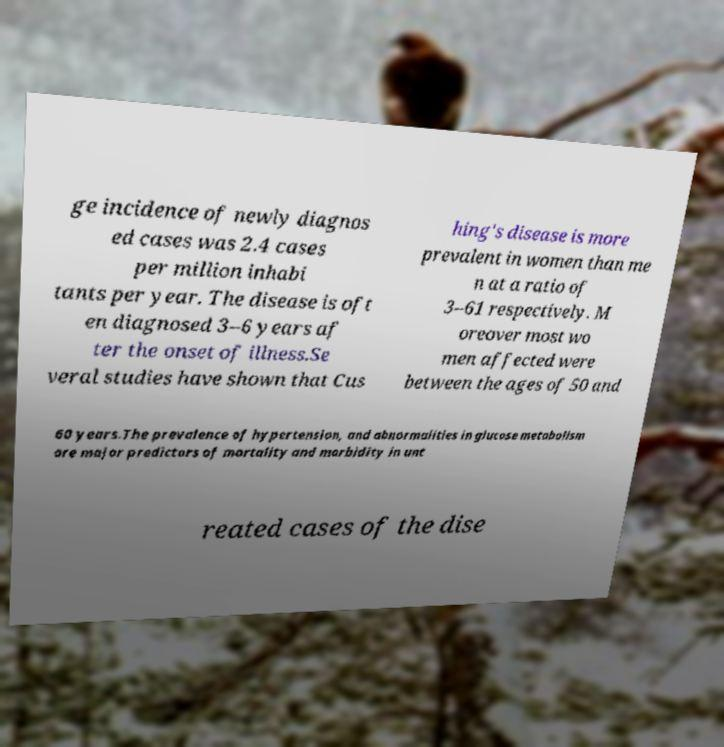For documentation purposes, I need the text within this image transcribed. Could you provide that? ge incidence of newly diagnos ed cases was 2.4 cases per million inhabi tants per year. The disease is oft en diagnosed 3–6 years af ter the onset of illness.Se veral studies have shown that Cus hing's disease is more prevalent in women than me n at a ratio of 3–61 respectively. M oreover most wo men affected were between the ages of 50 and 60 years.The prevalence of hypertension, and abnormalities in glucose metabolism are major predictors of mortality and morbidity in unt reated cases of the dise 